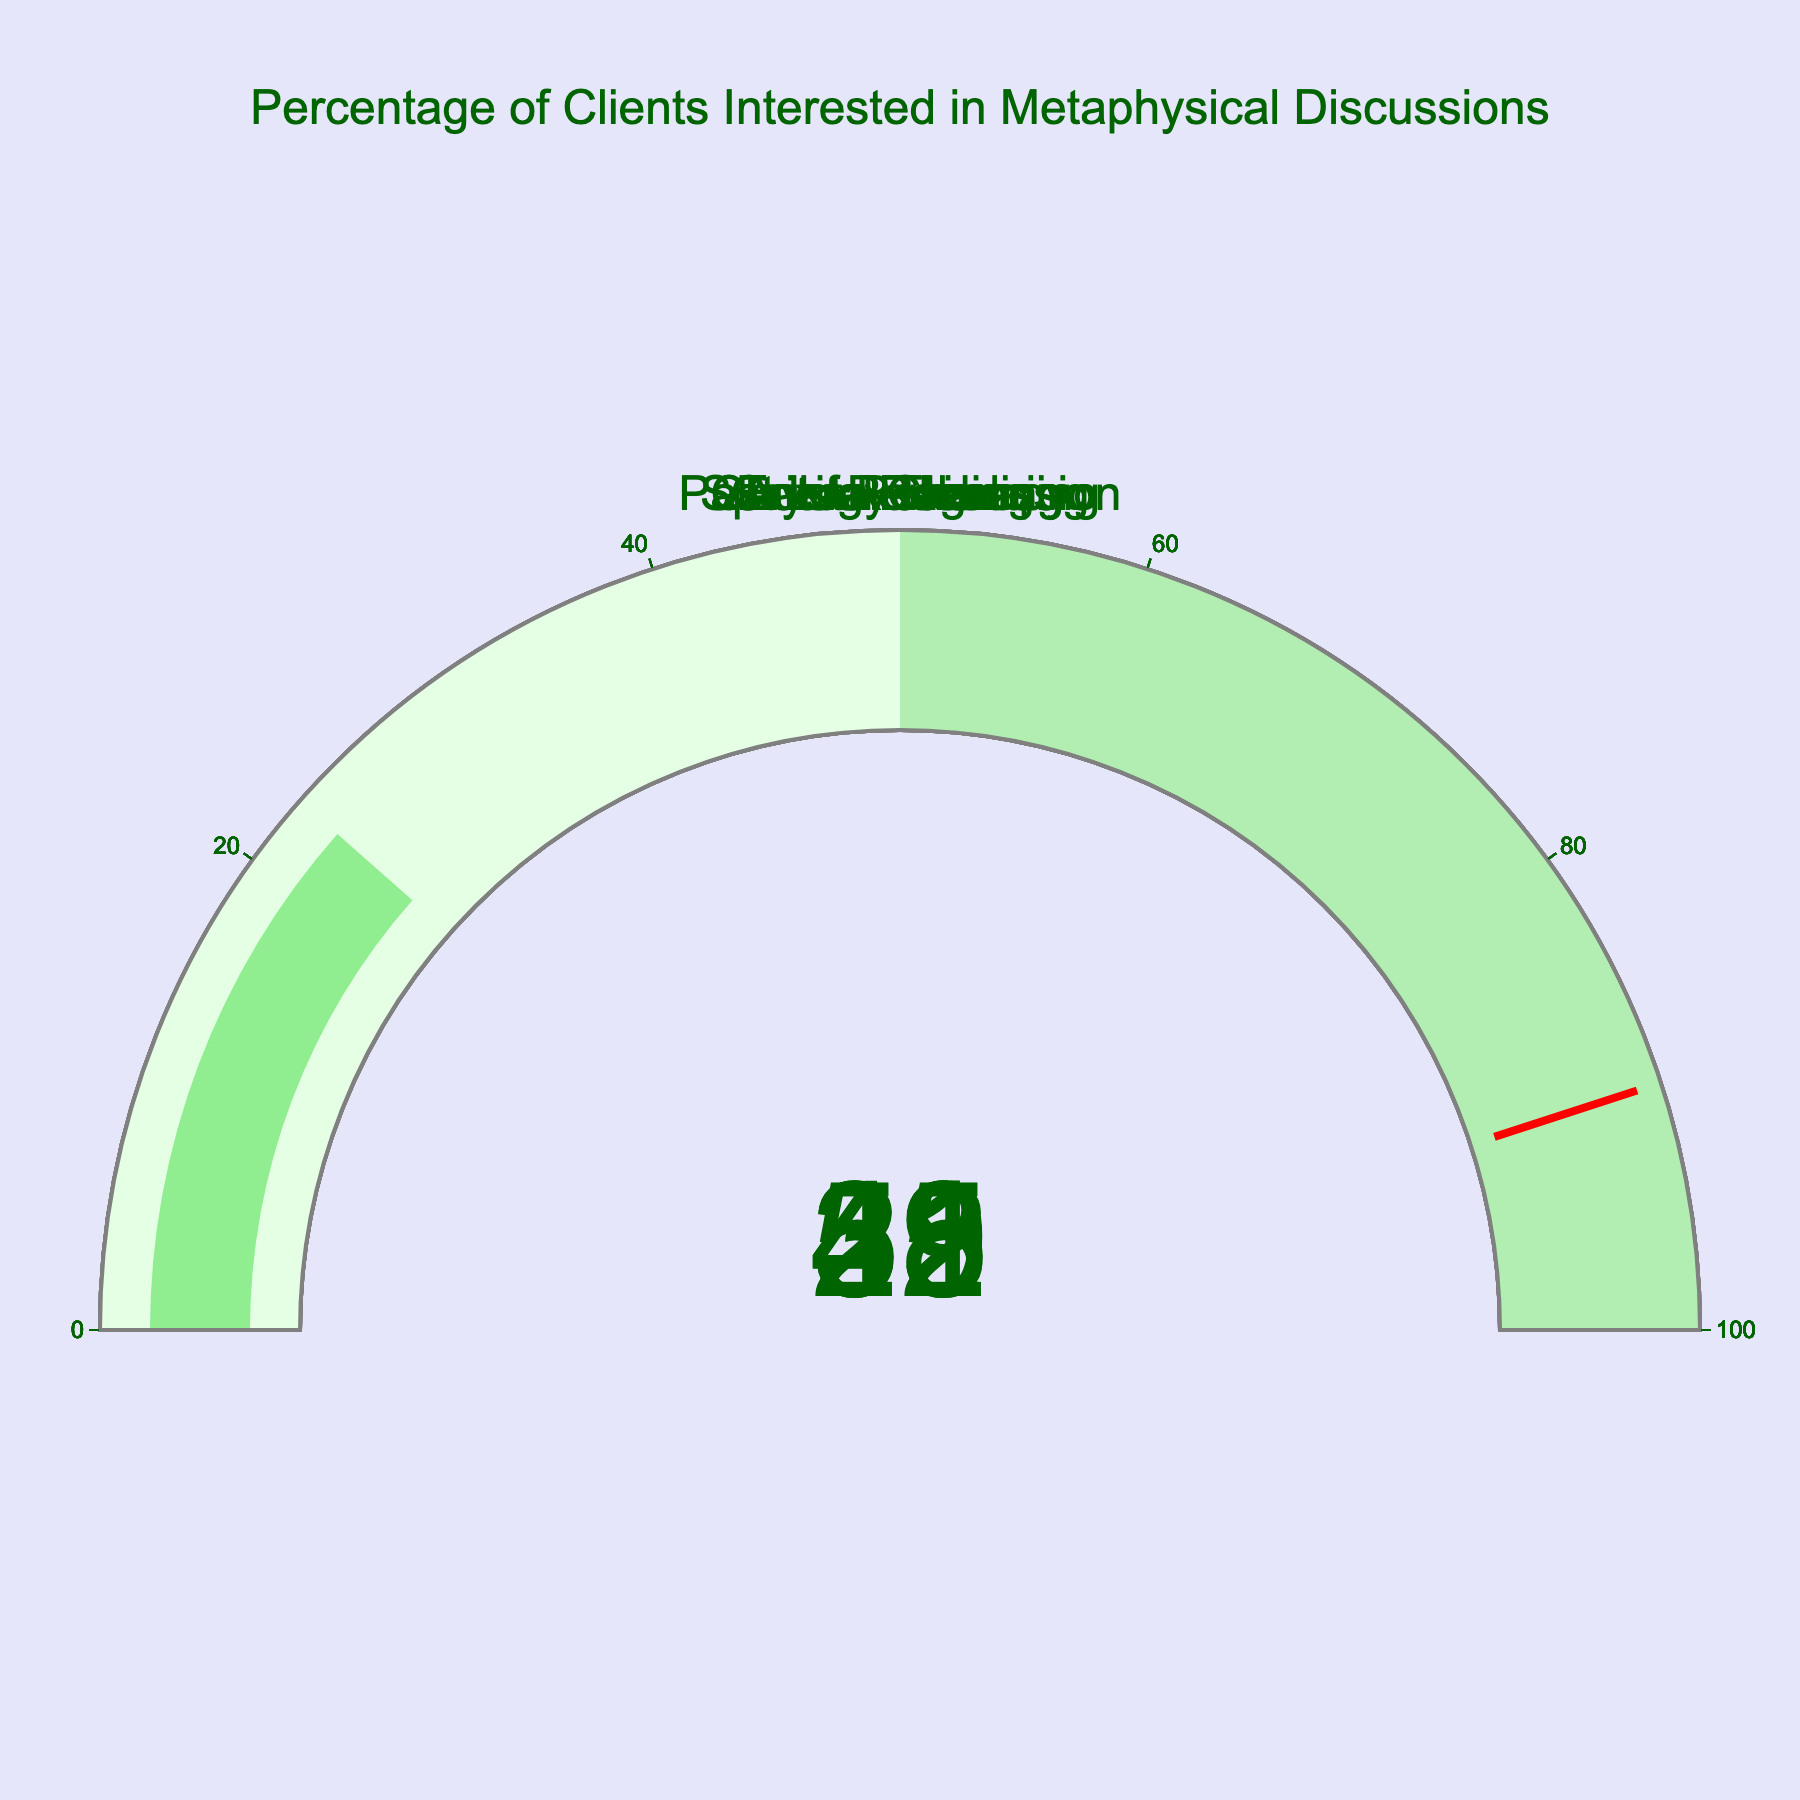How many topics are represented in the figure? Count the number of gauge plots displayed. There are 7 topics corresponding to 7 gauges.
Answer: 7 Which topic has the highest percentage of clients interested in metaphysical discussions? Identify the gauge with the highest displayed value. Reiki has the highest percentage at 52%.
Answer: Reiki What is the median percentage of clients interested in metaphysical discussions across all topics? Arrange the percentages in ascending order: 23, 29, 32, 38, 41, 45, 52. The median is the fourth value in this list.
Answer: 38 How many topics have more than 40% of clients interested in metaphysical discussions? Identify the gauges with values greater than 40%. Energy Healing, Reiki, and Crystal Therapy have more than 40%, totaling 3 topics.
Answer: 3 Which topics have the exact same percentage of clients interested in metaphysical discussions? Compare the percentages of each topic. No topics have the exact same percentage.
Answer: None What is the percentage difference between Reiki and Past Life Regression? Subtract the percentage of Past Life Regression from Reiki: 52 - 23.
Answer: 29 Which topic has a percentage closest to 30% of clients interested in metaphysical discussions? Check the percentages and identify the one closest to 30%. Spiritual Cleansing at 29% is the closest.
Answer: Spiritual Cleansing Is the percentage of clients interested in Chakra Balancing greater or less than the percentage interested in Energy Healing? Compare the percentages: Chakra Balancing (38%) vs Energy Healing (45%). Chakra Balancing is less.
Answer: Less What is the range of percentages for all topics? Subtract the smallest percentage from the largest: 52 (Reiki) - 23 (Past Life Regression).
Answer: 29 What percentage of clients are interested in Chakra Balancing and Crystal Therapy combined? Sum the percentages of Chakra Balancing and Crystal Therapy: 38 + 41.
Answer: 79 